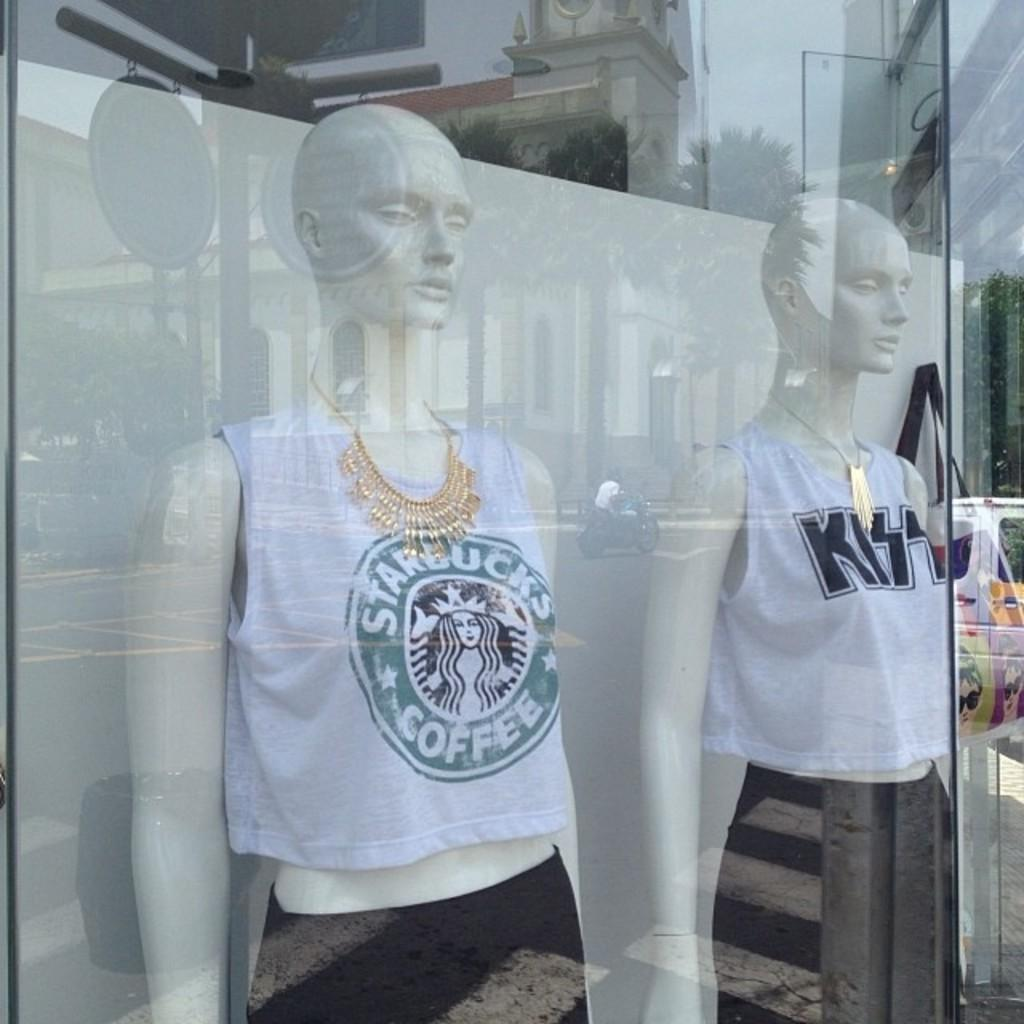<image>
Present a compact description of the photo's key features. Two mannequins on display wearing Starbucks and Kiss shirts. 